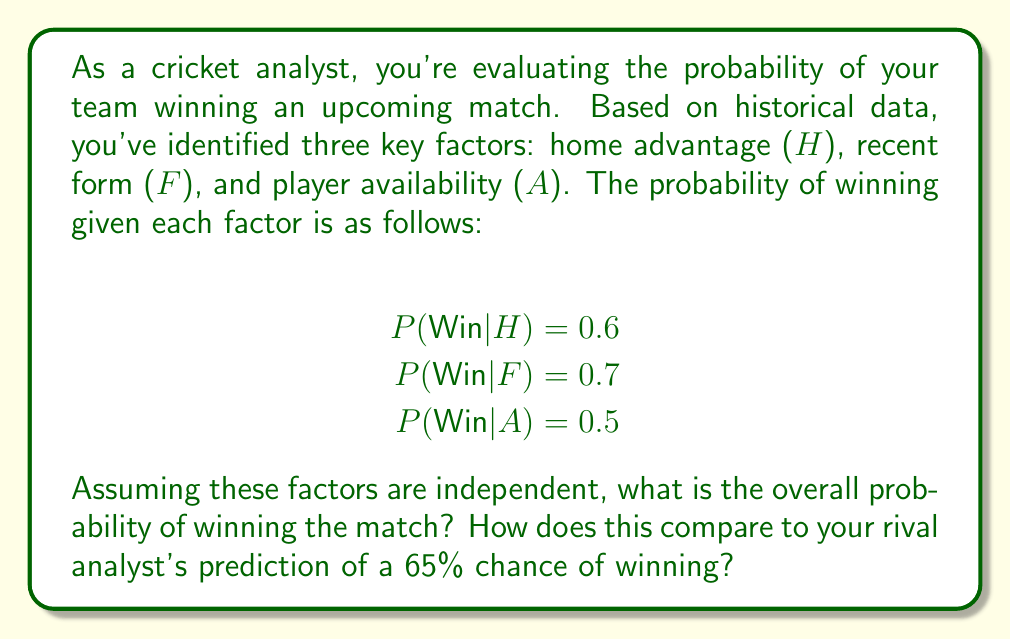Can you answer this question? To solve this problem, we'll use decision analysis techniques, specifically the multiplication rule for independent events.

1) First, we need to calculate the probability of winning given all three factors. Since the factors are independent, we multiply their individual probabilities:

   $$P(Win|H,F,A) = P(Win|H) \times P(Win|F) \times P(Win|A)$$

2) Substituting the given values:

   $$P(Win|H,F,A) = 0.6 \times 0.7 \times 0.5$$

3) Calculating:

   $$P(Win|H,F,A) = 0.21 = 21\%$$

4) To compare with the rival analyst's prediction, we calculate the difference:

   $$\text{Difference} = 65\% - 21\% = 44\%$$

This significant difference suggests that the rival analyst may be overestimating the team's chances of winning, or they may be considering additional factors not included in our analysis.

5) To further analyze this discrepancy, we could:
   - Investigate if there are other relevant factors not considered in our model
   - Check if the assumption of independence holds for these factors
   - Verify the accuracy of our historical data and probability estimates

This analysis demonstrates the importance of considering multiple factors and their interactions in sports predictions, as well as the potential for differing opinions among analysts based on their methodology and data sources.
Answer: The overall probability of winning the match, given the three independent factors, is 21%. This is 44 percentage points lower than the rival analyst's prediction of 65%. 